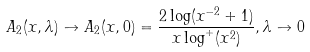<formula> <loc_0><loc_0><loc_500><loc_500>A _ { 2 } ( x , \lambda ) \to A _ { 2 } ( x , 0 ) = \frac { 2 \log ( x ^ { - 2 } + 1 ) } { x \log ^ { + } ( x ^ { 2 } ) } , \lambda \to 0</formula> 